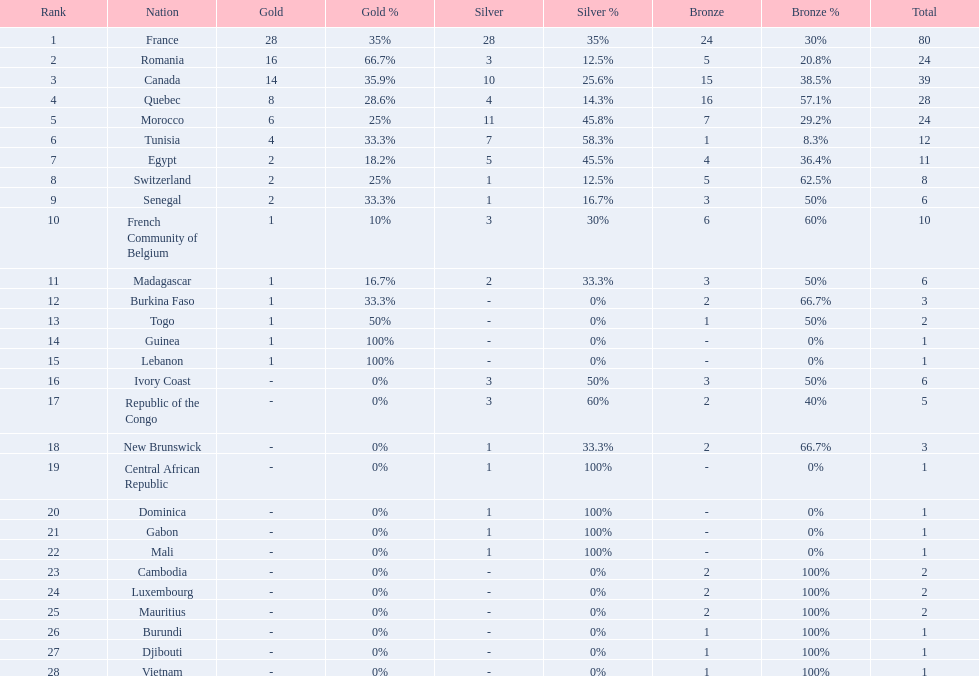Who placed in first according to medals? France. 